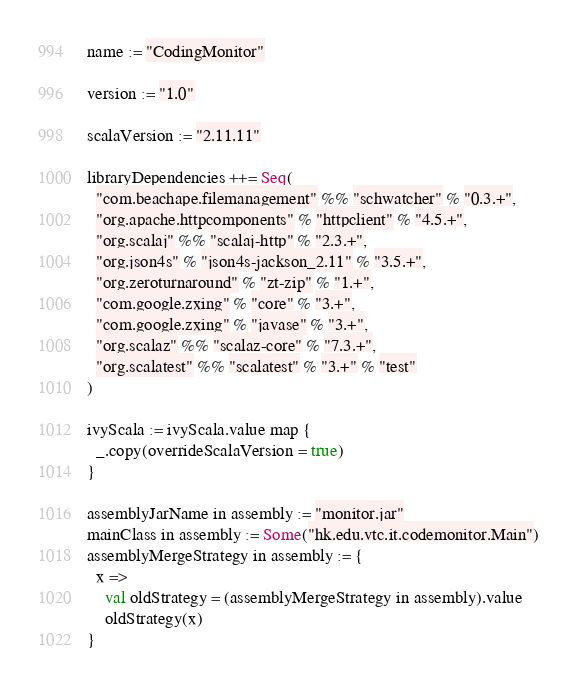<code> <loc_0><loc_0><loc_500><loc_500><_Scala_>name := "CodingMonitor"

version := "1.0"

scalaVersion := "2.11.11"

libraryDependencies ++= Seq(
  "com.beachape.filemanagement" %% "schwatcher" % "0.3.+",
  "org.apache.httpcomponents" % "httpclient" % "4.5.+",
  "org.scalaj" %% "scalaj-http" % "2.3.+",
  "org.json4s" % "json4s-jackson_2.11" % "3.5.+",
  "org.zeroturnaround" % "zt-zip" % "1.+",
  "com.google.zxing" % "core" % "3.+",
  "com.google.zxing" % "javase" % "3.+",
  "org.scalaz" %% "scalaz-core" % "7.3.+",
  "org.scalatest" %% "scalatest" % "3.+" % "test"
)

ivyScala := ivyScala.value map {
  _.copy(overrideScalaVersion = true)
}

assemblyJarName in assembly := "monitor.jar"
mainClass in assembly := Some("hk.edu.vtc.it.codemonitor.Main")
assemblyMergeStrategy in assembly := {
  x =>
    val oldStrategy = (assemblyMergeStrategy in assembly).value
    oldStrategy(x)
}</code> 